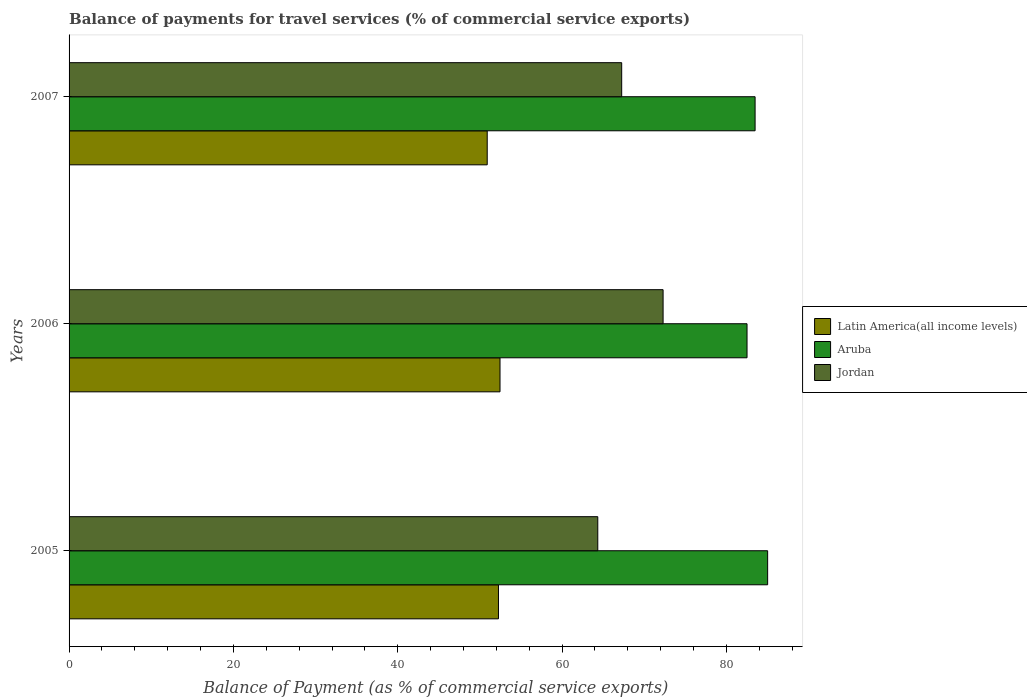How many different coloured bars are there?
Give a very brief answer. 3. Are the number of bars on each tick of the Y-axis equal?
Your answer should be compact. Yes. How many bars are there on the 2nd tick from the top?
Offer a terse response. 3. How many bars are there on the 3rd tick from the bottom?
Offer a terse response. 3. What is the label of the 1st group of bars from the top?
Give a very brief answer. 2007. What is the balance of payments for travel services in Jordan in 2006?
Keep it short and to the point. 72.29. Across all years, what is the maximum balance of payments for travel services in Jordan?
Your answer should be compact. 72.29. Across all years, what is the minimum balance of payments for travel services in Latin America(all income levels)?
Keep it short and to the point. 50.89. In which year was the balance of payments for travel services in Latin America(all income levels) maximum?
Your answer should be very brief. 2006. What is the total balance of payments for travel services in Latin America(all income levels) in the graph?
Your answer should be very brief. 155.58. What is the difference between the balance of payments for travel services in Latin America(all income levels) in 2006 and that in 2007?
Your answer should be compact. 1.56. What is the difference between the balance of payments for travel services in Aruba in 2006 and the balance of payments for travel services in Jordan in 2005?
Make the answer very short. 18.16. What is the average balance of payments for travel services in Jordan per year?
Provide a succinct answer. 67.96. In the year 2005, what is the difference between the balance of payments for travel services in Aruba and balance of payments for travel services in Jordan?
Give a very brief answer. 20.67. In how many years, is the balance of payments for travel services in Aruba greater than 64 %?
Ensure brevity in your answer.  3. What is the ratio of the balance of payments for travel services in Aruba in 2005 to that in 2007?
Provide a short and direct response. 1.02. What is the difference between the highest and the second highest balance of payments for travel services in Latin America(all income levels)?
Ensure brevity in your answer.  0.19. What is the difference between the highest and the lowest balance of payments for travel services in Jordan?
Ensure brevity in your answer.  7.95. What does the 3rd bar from the top in 2005 represents?
Offer a very short reply. Latin America(all income levels). What does the 3rd bar from the bottom in 2005 represents?
Ensure brevity in your answer.  Jordan. Is it the case that in every year, the sum of the balance of payments for travel services in Jordan and balance of payments for travel services in Latin America(all income levels) is greater than the balance of payments for travel services in Aruba?
Your response must be concise. Yes. How many bars are there?
Keep it short and to the point. 9. Are all the bars in the graph horizontal?
Your answer should be very brief. Yes. What is the difference between two consecutive major ticks on the X-axis?
Your response must be concise. 20. Are the values on the major ticks of X-axis written in scientific E-notation?
Provide a short and direct response. No. Does the graph contain any zero values?
Keep it short and to the point. No. Does the graph contain grids?
Give a very brief answer. No. How are the legend labels stacked?
Your response must be concise. Vertical. What is the title of the graph?
Offer a terse response. Balance of payments for travel services (% of commercial service exports). Does "St. Vincent and the Grenadines" appear as one of the legend labels in the graph?
Give a very brief answer. No. What is the label or title of the X-axis?
Offer a very short reply. Balance of Payment (as % of commercial service exports). What is the Balance of Payment (as % of commercial service exports) of Latin America(all income levels) in 2005?
Your answer should be compact. 52.25. What is the Balance of Payment (as % of commercial service exports) of Aruba in 2005?
Offer a very short reply. 85.01. What is the Balance of Payment (as % of commercial service exports) in Jordan in 2005?
Your answer should be compact. 64.34. What is the Balance of Payment (as % of commercial service exports) in Latin America(all income levels) in 2006?
Make the answer very short. 52.44. What is the Balance of Payment (as % of commercial service exports) of Aruba in 2006?
Provide a succinct answer. 82.5. What is the Balance of Payment (as % of commercial service exports) in Jordan in 2006?
Your answer should be compact. 72.29. What is the Balance of Payment (as % of commercial service exports) of Latin America(all income levels) in 2007?
Provide a succinct answer. 50.89. What is the Balance of Payment (as % of commercial service exports) in Aruba in 2007?
Your response must be concise. 83.48. What is the Balance of Payment (as % of commercial service exports) of Jordan in 2007?
Make the answer very short. 67.25. Across all years, what is the maximum Balance of Payment (as % of commercial service exports) in Latin America(all income levels)?
Provide a succinct answer. 52.44. Across all years, what is the maximum Balance of Payment (as % of commercial service exports) of Aruba?
Your answer should be very brief. 85.01. Across all years, what is the maximum Balance of Payment (as % of commercial service exports) of Jordan?
Your response must be concise. 72.29. Across all years, what is the minimum Balance of Payment (as % of commercial service exports) in Latin America(all income levels)?
Make the answer very short. 50.89. Across all years, what is the minimum Balance of Payment (as % of commercial service exports) in Aruba?
Offer a very short reply. 82.5. Across all years, what is the minimum Balance of Payment (as % of commercial service exports) of Jordan?
Your answer should be very brief. 64.34. What is the total Balance of Payment (as % of commercial service exports) in Latin America(all income levels) in the graph?
Offer a very short reply. 155.58. What is the total Balance of Payment (as % of commercial service exports) in Aruba in the graph?
Keep it short and to the point. 251. What is the total Balance of Payment (as % of commercial service exports) of Jordan in the graph?
Keep it short and to the point. 203.88. What is the difference between the Balance of Payment (as % of commercial service exports) of Latin America(all income levels) in 2005 and that in 2006?
Your answer should be very brief. -0.19. What is the difference between the Balance of Payment (as % of commercial service exports) of Aruba in 2005 and that in 2006?
Your answer should be compact. 2.51. What is the difference between the Balance of Payment (as % of commercial service exports) in Jordan in 2005 and that in 2006?
Give a very brief answer. -7.95. What is the difference between the Balance of Payment (as % of commercial service exports) in Latin America(all income levels) in 2005 and that in 2007?
Offer a very short reply. 1.37. What is the difference between the Balance of Payment (as % of commercial service exports) in Aruba in 2005 and that in 2007?
Offer a very short reply. 1.53. What is the difference between the Balance of Payment (as % of commercial service exports) of Jordan in 2005 and that in 2007?
Your answer should be compact. -2.91. What is the difference between the Balance of Payment (as % of commercial service exports) in Latin America(all income levels) in 2006 and that in 2007?
Your response must be concise. 1.56. What is the difference between the Balance of Payment (as % of commercial service exports) of Aruba in 2006 and that in 2007?
Keep it short and to the point. -0.98. What is the difference between the Balance of Payment (as % of commercial service exports) in Jordan in 2006 and that in 2007?
Offer a very short reply. 5.04. What is the difference between the Balance of Payment (as % of commercial service exports) of Latin America(all income levels) in 2005 and the Balance of Payment (as % of commercial service exports) of Aruba in 2006?
Offer a terse response. -30.25. What is the difference between the Balance of Payment (as % of commercial service exports) of Latin America(all income levels) in 2005 and the Balance of Payment (as % of commercial service exports) of Jordan in 2006?
Offer a very short reply. -20.03. What is the difference between the Balance of Payment (as % of commercial service exports) in Aruba in 2005 and the Balance of Payment (as % of commercial service exports) in Jordan in 2006?
Keep it short and to the point. 12.72. What is the difference between the Balance of Payment (as % of commercial service exports) in Latin America(all income levels) in 2005 and the Balance of Payment (as % of commercial service exports) in Aruba in 2007?
Provide a short and direct response. -31.23. What is the difference between the Balance of Payment (as % of commercial service exports) of Latin America(all income levels) in 2005 and the Balance of Payment (as % of commercial service exports) of Jordan in 2007?
Ensure brevity in your answer.  -14.99. What is the difference between the Balance of Payment (as % of commercial service exports) of Aruba in 2005 and the Balance of Payment (as % of commercial service exports) of Jordan in 2007?
Provide a short and direct response. 17.76. What is the difference between the Balance of Payment (as % of commercial service exports) of Latin America(all income levels) in 2006 and the Balance of Payment (as % of commercial service exports) of Aruba in 2007?
Your answer should be compact. -31.04. What is the difference between the Balance of Payment (as % of commercial service exports) in Latin America(all income levels) in 2006 and the Balance of Payment (as % of commercial service exports) in Jordan in 2007?
Ensure brevity in your answer.  -14.81. What is the difference between the Balance of Payment (as % of commercial service exports) in Aruba in 2006 and the Balance of Payment (as % of commercial service exports) in Jordan in 2007?
Give a very brief answer. 15.25. What is the average Balance of Payment (as % of commercial service exports) in Latin America(all income levels) per year?
Keep it short and to the point. 51.86. What is the average Balance of Payment (as % of commercial service exports) in Aruba per year?
Offer a terse response. 83.67. What is the average Balance of Payment (as % of commercial service exports) of Jordan per year?
Make the answer very short. 67.96. In the year 2005, what is the difference between the Balance of Payment (as % of commercial service exports) of Latin America(all income levels) and Balance of Payment (as % of commercial service exports) of Aruba?
Provide a succinct answer. -32.76. In the year 2005, what is the difference between the Balance of Payment (as % of commercial service exports) of Latin America(all income levels) and Balance of Payment (as % of commercial service exports) of Jordan?
Provide a succinct answer. -12.09. In the year 2005, what is the difference between the Balance of Payment (as % of commercial service exports) in Aruba and Balance of Payment (as % of commercial service exports) in Jordan?
Provide a short and direct response. 20.67. In the year 2006, what is the difference between the Balance of Payment (as % of commercial service exports) of Latin America(all income levels) and Balance of Payment (as % of commercial service exports) of Aruba?
Give a very brief answer. -30.06. In the year 2006, what is the difference between the Balance of Payment (as % of commercial service exports) of Latin America(all income levels) and Balance of Payment (as % of commercial service exports) of Jordan?
Your answer should be very brief. -19.85. In the year 2006, what is the difference between the Balance of Payment (as % of commercial service exports) of Aruba and Balance of Payment (as % of commercial service exports) of Jordan?
Provide a succinct answer. 10.21. In the year 2007, what is the difference between the Balance of Payment (as % of commercial service exports) in Latin America(all income levels) and Balance of Payment (as % of commercial service exports) in Aruba?
Make the answer very short. -32.6. In the year 2007, what is the difference between the Balance of Payment (as % of commercial service exports) in Latin America(all income levels) and Balance of Payment (as % of commercial service exports) in Jordan?
Your response must be concise. -16.36. In the year 2007, what is the difference between the Balance of Payment (as % of commercial service exports) of Aruba and Balance of Payment (as % of commercial service exports) of Jordan?
Provide a succinct answer. 16.24. What is the ratio of the Balance of Payment (as % of commercial service exports) in Latin America(all income levels) in 2005 to that in 2006?
Keep it short and to the point. 1. What is the ratio of the Balance of Payment (as % of commercial service exports) in Aruba in 2005 to that in 2006?
Ensure brevity in your answer.  1.03. What is the ratio of the Balance of Payment (as % of commercial service exports) in Jordan in 2005 to that in 2006?
Provide a succinct answer. 0.89. What is the ratio of the Balance of Payment (as % of commercial service exports) in Latin America(all income levels) in 2005 to that in 2007?
Your response must be concise. 1.03. What is the ratio of the Balance of Payment (as % of commercial service exports) of Aruba in 2005 to that in 2007?
Your answer should be very brief. 1.02. What is the ratio of the Balance of Payment (as % of commercial service exports) of Jordan in 2005 to that in 2007?
Provide a short and direct response. 0.96. What is the ratio of the Balance of Payment (as % of commercial service exports) in Latin America(all income levels) in 2006 to that in 2007?
Ensure brevity in your answer.  1.03. What is the ratio of the Balance of Payment (as % of commercial service exports) of Jordan in 2006 to that in 2007?
Offer a terse response. 1.07. What is the difference between the highest and the second highest Balance of Payment (as % of commercial service exports) in Latin America(all income levels)?
Offer a very short reply. 0.19. What is the difference between the highest and the second highest Balance of Payment (as % of commercial service exports) in Aruba?
Your response must be concise. 1.53. What is the difference between the highest and the second highest Balance of Payment (as % of commercial service exports) in Jordan?
Offer a terse response. 5.04. What is the difference between the highest and the lowest Balance of Payment (as % of commercial service exports) in Latin America(all income levels)?
Your answer should be very brief. 1.56. What is the difference between the highest and the lowest Balance of Payment (as % of commercial service exports) in Aruba?
Make the answer very short. 2.51. What is the difference between the highest and the lowest Balance of Payment (as % of commercial service exports) of Jordan?
Your answer should be very brief. 7.95. 